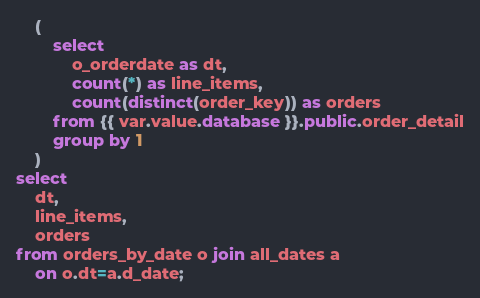Convert code to text. <code><loc_0><loc_0><loc_500><loc_500><_SQL_>    (
        select
            o_orderdate as dt,
            count(*) as line_items,
            count(distinct(order_key)) as orders
        from {{ var.value.database }}.public.order_detail
        group by 1
    )
select
    dt,
    line_items,
    orders
from orders_by_date o join all_dates a
    on o.dt=a.d_date;</code> 